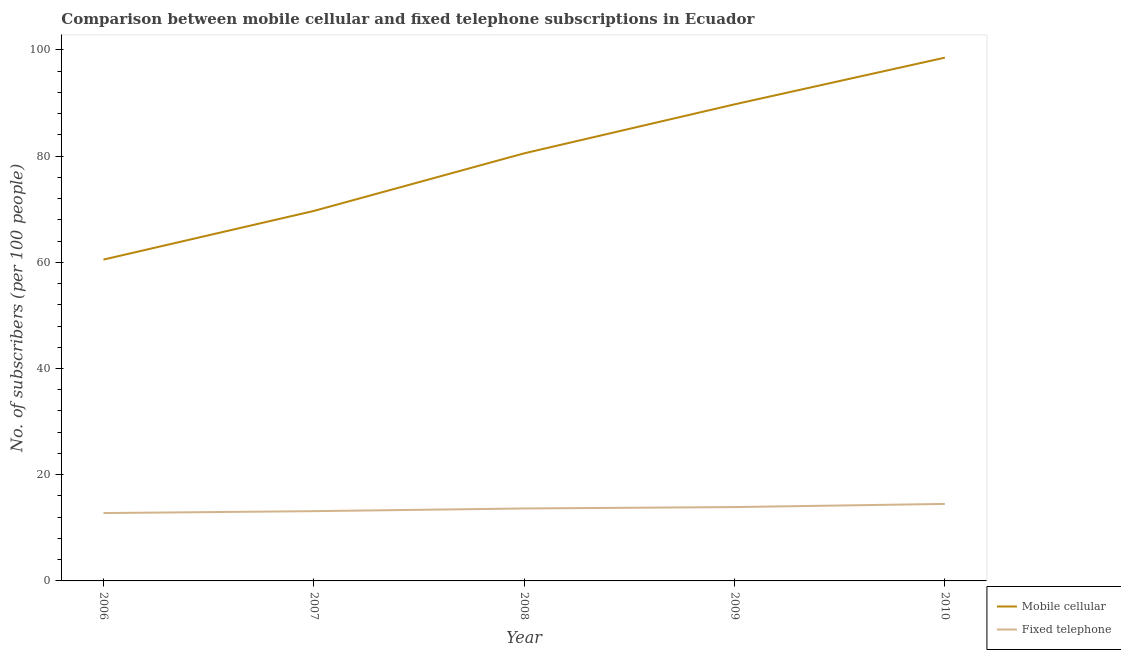How many different coloured lines are there?
Ensure brevity in your answer.  2. Does the line corresponding to number of fixed telephone subscribers intersect with the line corresponding to number of mobile cellular subscribers?
Ensure brevity in your answer.  No. Is the number of lines equal to the number of legend labels?
Ensure brevity in your answer.  Yes. What is the number of fixed telephone subscribers in 2007?
Provide a short and direct response. 13.14. Across all years, what is the maximum number of mobile cellular subscribers?
Make the answer very short. 98.53. Across all years, what is the minimum number of fixed telephone subscribers?
Ensure brevity in your answer.  12.78. In which year was the number of fixed telephone subscribers maximum?
Provide a succinct answer. 2010. In which year was the number of mobile cellular subscribers minimum?
Give a very brief answer. 2006. What is the total number of fixed telephone subscribers in the graph?
Keep it short and to the point. 67.96. What is the difference between the number of fixed telephone subscribers in 2007 and that in 2008?
Offer a very short reply. -0.51. What is the difference between the number of mobile cellular subscribers in 2007 and the number of fixed telephone subscribers in 2006?
Provide a short and direct response. 56.89. What is the average number of fixed telephone subscribers per year?
Your response must be concise. 13.59. In the year 2006, what is the difference between the number of fixed telephone subscribers and number of mobile cellular subscribers?
Give a very brief answer. -47.73. What is the ratio of the number of mobile cellular subscribers in 2008 to that in 2010?
Your answer should be very brief. 0.82. What is the difference between the highest and the second highest number of fixed telephone subscribers?
Your answer should be very brief. 0.6. What is the difference between the highest and the lowest number of mobile cellular subscribers?
Provide a short and direct response. 38.03. In how many years, is the number of fixed telephone subscribers greater than the average number of fixed telephone subscribers taken over all years?
Offer a terse response. 3. Does the number of mobile cellular subscribers monotonically increase over the years?
Ensure brevity in your answer.  Yes. Is the number of fixed telephone subscribers strictly greater than the number of mobile cellular subscribers over the years?
Ensure brevity in your answer.  No. Is the number of mobile cellular subscribers strictly less than the number of fixed telephone subscribers over the years?
Offer a very short reply. No. How many lines are there?
Provide a short and direct response. 2. What is the difference between two consecutive major ticks on the Y-axis?
Your answer should be very brief. 20. Does the graph contain grids?
Provide a short and direct response. No. Where does the legend appear in the graph?
Your answer should be very brief. Bottom right. How are the legend labels stacked?
Offer a very short reply. Vertical. What is the title of the graph?
Offer a very short reply. Comparison between mobile cellular and fixed telephone subscriptions in Ecuador. Does "Females" appear as one of the legend labels in the graph?
Offer a very short reply. No. What is the label or title of the Y-axis?
Your answer should be very brief. No. of subscribers (per 100 people). What is the No. of subscribers (per 100 people) of Mobile cellular in 2006?
Offer a terse response. 60.51. What is the No. of subscribers (per 100 people) of Fixed telephone in 2006?
Provide a succinct answer. 12.78. What is the No. of subscribers (per 100 people) in Mobile cellular in 2007?
Give a very brief answer. 69.66. What is the No. of subscribers (per 100 people) of Fixed telephone in 2007?
Keep it short and to the point. 13.14. What is the No. of subscribers (per 100 people) of Mobile cellular in 2008?
Your answer should be very brief. 80.51. What is the No. of subscribers (per 100 people) in Fixed telephone in 2008?
Offer a very short reply. 13.64. What is the No. of subscribers (per 100 people) of Mobile cellular in 2009?
Give a very brief answer. 89.74. What is the No. of subscribers (per 100 people) of Fixed telephone in 2009?
Ensure brevity in your answer.  13.9. What is the No. of subscribers (per 100 people) in Mobile cellular in 2010?
Offer a very short reply. 98.53. What is the No. of subscribers (per 100 people) in Fixed telephone in 2010?
Your answer should be very brief. 14.5. Across all years, what is the maximum No. of subscribers (per 100 people) of Mobile cellular?
Ensure brevity in your answer.  98.53. Across all years, what is the maximum No. of subscribers (per 100 people) in Fixed telephone?
Ensure brevity in your answer.  14.5. Across all years, what is the minimum No. of subscribers (per 100 people) of Mobile cellular?
Your answer should be very brief. 60.51. Across all years, what is the minimum No. of subscribers (per 100 people) of Fixed telephone?
Ensure brevity in your answer.  12.78. What is the total No. of subscribers (per 100 people) in Mobile cellular in the graph?
Keep it short and to the point. 398.95. What is the total No. of subscribers (per 100 people) of Fixed telephone in the graph?
Offer a terse response. 67.96. What is the difference between the No. of subscribers (per 100 people) of Mobile cellular in 2006 and that in 2007?
Offer a very short reply. -9.16. What is the difference between the No. of subscribers (per 100 people) of Fixed telephone in 2006 and that in 2007?
Offer a very short reply. -0.36. What is the difference between the No. of subscribers (per 100 people) of Mobile cellular in 2006 and that in 2008?
Offer a terse response. -20.01. What is the difference between the No. of subscribers (per 100 people) in Fixed telephone in 2006 and that in 2008?
Provide a succinct answer. -0.87. What is the difference between the No. of subscribers (per 100 people) in Mobile cellular in 2006 and that in 2009?
Keep it short and to the point. -29.23. What is the difference between the No. of subscribers (per 100 people) in Fixed telephone in 2006 and that in 2009?
Make the answer very short. -1.13. What is the difference between the No. of subscribers (per 100 people) of Mobile cellular in 2006 and that in 2010?
Provide a short and direct response. -38.03. What is the difference between the No. of subscribers (per 100 people) of Fixed telephone in 2006 and that in 2010?
Keep it short and to the point. -1.72. What is the difference between the No. of subscribers (per 100 people) in Mobile cellular in 2007 and that in 2008?
Ensure brevity in your answer.  -10.85. What is the difference between the No. of subscribers (per 100 people) of Fixed telephone in 2007 and that in 2008?
Provide a succinct answer. -0.51. What is the difference between the No. of subscribers (per 100 people) of Mobile cellular in 2007 and that in 2009?
Give a very brief answer. -20.07. What is the difference between the No. of subscribers (per 100 people) in Fixed telephone in 2007 and that in 2009?
Keep it short and to the point. -0.77. What is the difference between the No. of subscribers (per 100 people) in Mobile cellular in 2007 and that in 2010?
Your response must be concise. -28.87. What is the difference between the No. of subscribers (per 100 people) of Fixed telephone in 2007 and that in 2010?
Your answer should be compact. -1.36. What is the difference between the No. of subscribers (per 100 people) of Mobile cellular in 2008 and that in 2009?
Your response must be concise. -9.22. What is the difference between the No. of subscribers (per 100 people) of Fixed telephone in 2008 and that in 2009?
Your response must be concise. -0.26. What is the difference between the No. of subscribers (per 100 people) in Mobile cellular in 2008 and that in 2010?
Your answer should be very brief. -18.02. What is the difference between the No. of subscribers (per 100 people) of Fixed telephone in 2008 and that in 2010?
Your response must be concise. -0.86. What is the difference between the No. of subscribers (per 100 people) of Mobile cellular in 2009 and that in 2010?
Offer a very short reply. -8.8. What is the difference between the No. of subscribers (per 100 people) in Fixed telephone in 2009 and that in 2010?
Keep it short and to the point. -0.6. What is the difference between the No. of subscribers (per 100 people) of Mobile cellular in 2006 and the No. of subscribers (per 100 people) of Fixed telephone in 2007?
Give a very brief answer. 47.37. What is the difference between the No. of subscribers (per 100 people) of Mobile cellular in 2006 and the No. of subscribers (per 100 people) of Fixed telephone in 2008?
Make the answer very short. 46.86. What is the difference between the No. of subscribers (per 100 people) in Mobile cellular in 2006 and the No. of subscribers (per 100 people) in Fixed telephone in 2009?
Your response must be concise. 46.6. What is the difference between the No. of subscribers (per 100 people) of Mobile cellular in 2006 and the No. of subscribers (per 100 people) of Fixed telephone in 2010?
Provide a succinct answer. 46.01. What is the difference between the No. of subscribers (per 100 people) in Mobile cellular in 2007 and the No. of subscribers (per 100 people) in Fixed telephone in 2008?
Offer a terse response. 56.02. What is the difference between the No. of subscribers (per 100 people) in Mobile cellular in 2007 and the No. of subscribers (per 100 people) in Fixed telephone in 2009?
Offer a terse response. 55.76. What is the difference between the No. of subscribers (per 100 people) of Mobile cellular in 2007 and the No. of subscribers (per 100 people) of Fixed telephone in 2010?
Provide a short and direct response. 55.17. What is the difference between the No. of subscribers (per 100 people) in Mobile cellular in 2008 and the No. of subscribers (per 100 people) in Fixed telephone in 2009?
Provide a short and direct response. 66.61. What is the difference between the No. of subscribers (per 100 people) in Mobile cellular in 2008 and the No. of subscribers (per 100 people) in Fixed telephone in 2010?
Make the answer very short. 66.01. What is the difference between the No. of subscribers (per 100 people) in Mobile cellular in 2009 and the No. of subscribers (per 100 people) in Fixed telephone in 2010?
Ensure brevity in your answer.  75.24. What is the average No. of subscribers (per 100 people) in Mobile cellular per year?
Keep it short and to the point. 79.79. What is the average No. of subscribers (per 100 people) in Fixed telephone per year?
Offer a very short reply. 13.59. In the year 2006, what is the difference between the No. of subscribers (per 100 people) in Mobile cellular and No. of subscribers (per 100 people) in Fixed telephone?
Offer a very short reply. 47.73. In the year 2007, what is the difference between the No. of subscribers (per 100 people) in Mobile cellular and No. of subscribers (per 100 people) in Fixed telephone?
Your response must be concise. 56.53. In the year 2008, what is the difference between the No. of subscribers (per 100 people) in Mobile cellular and No. of subscribers (per 100 people) in Fixed telephone?
Your response must be concise. 66.87. In the year 2009, what is the difference between the No. of subscribers (per 100 people) of Mobile cellular and No. of subscribers (per 100 people) of Fixed telephone?
Make the answer very short. 75.83. In the year 2010, what is the difference between the No. of subscribers (per 100 people) in Mobile cellular and No. of subscribers (per 100 people) in Fixed telephone?
Ensure brevity in your answer.  84.03. What is the ratio of the No. of subscribers (per 100 people) in Mobile cellular in 2006 to that in 2007?
Your response must be concise. 0.87. What is the ratio of the No. of subscribers (per 100 people) of Fixed telephone in 2006 to that in 2007?
Offer a terse response. 0.97. What is the ratio of the No. of subscribers (per 100 people) of Mobile cellular in 2006 to that in 2008?
Your answer should be compact. 0.75. What is the ratio of the No. of subscribers (per 100 people) in Fixed telephone in 2006 to that in 2008?
Offer a terse response. 0.94. What is the ratio of the No. of subscribers (per 100 people) of Mobile cellular in 2006 to that in 2009?
Give a very brief answer. 0.67. What is the ratio of the No. of subscribers (per 100 people) of Fixed telephone in 2006 to that in 2009?
Ensure brevity in your answer.  0.92. What is the ratio of the No. of subscribers (per 100 people) in Mobile cellular in 2006 to that in 2010?
Make the answer very short. 0.61. What is the ratio of the No. of subscribers (per 100 people) of Fixed telephone in 2006 to that in 2010?
Keep it short and to the point. 0.88. What is the ratio of the No. of subscribers (per 100 people) in Mobile cellular in 2007 to that in 2008?
Give a very brief answer. 0.87. What is the ratio of the No. of subscribers (per 100 people) of Fixed telephone in 2007 to that in 2008?
Provide a short and direct response. 0.96. What is the ratio of the No. of subscribers (per 100 people) of Mobile cellular in 2007 to that in 2009?
Offer a terse response. 0.78. What is the ratio of the No. of subscribers (per 100 people) in Fixed telephone in 2007 to that in 2009?
Your response must be concise. 0.94. What is the ratio of the No. of subscribers (per 100 people) of Mobile cellular in 2007 to that in 2010?
Your answer should be very brief. 0.71. What is the ratio of the No. of subscribers (per 100 people) of Fixed telephone in 2007 to that in 2010?
Your response must be concise. 0.91. What is the ratio of the No. of subscribers (per 100 people) of Mobile cellular in 2008 to that in 2009?
Provide a succinct answer. 0.9. What is the ratio of the No. of subscribers (per 100 people) in Fixed telephone in 2008 to that in 2009?
Provide a short and direct response. 0.98. What is the ratio of the No. of subscribers (per 100 people) of Mobile cellular in 2008 to that in 2010?
Your answer should be compact. 0.82. What is the ratio of the No. of subscribers (per 100 people) of Fixed telephone in 2008 to that in 2010?
Ensure brevity in your answer.  0.94. What is the ratio of the No. of subscribers (per 100 people) in Mobile cellular in 2009 to that in 2010?
Your answer should be very brief. 0.91. What is the ratio of the No. of subscribers (per 100 people) of Fixed telephone in 2009 to that in 2010?
Offer a terse response. 0.96. What is the difference between the highest and the second highest No. of subscribers (per 100 people) of Mobile cellular?
Provide a succinct answer. 8.8. What is the difference between the highest and the second highest No. of subscribers (per 100 people) in Fixed telephone?
Give a very brief answer. 0.6. What is the difference between the highest and the lowest No. of subscribers (per 100 people) of Mobile cellular?
Your answer should be very brief. 38.03. What is the difference between the highest and the lowest No. of subscribers (per 100 people) of Fixed telephone?
Provide a short and direct response. 1.72. 